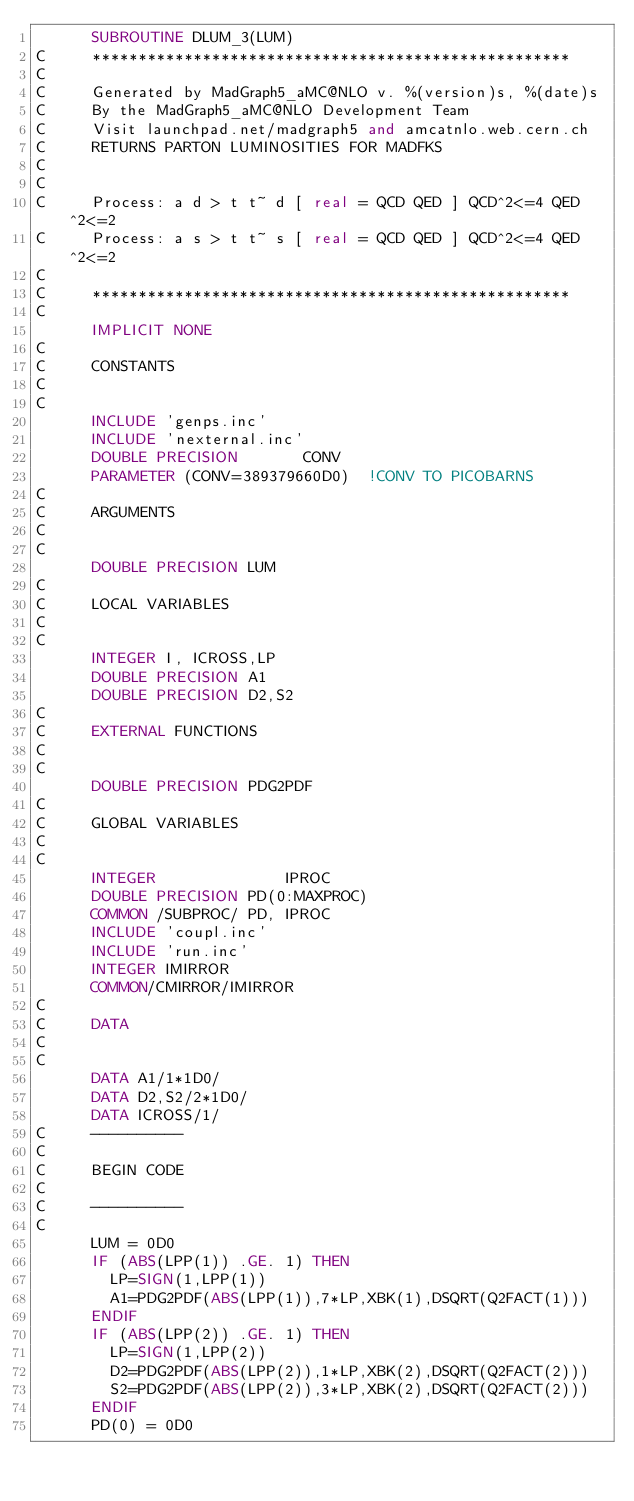<code> <loc_0><loc_0><loc_500><loc_500><_FORTRAN_>      SUBROUTINE DLUM_3(LUM)
C     ****************************************************            
C         
C     Generated by MadGraph5_aMC@NLO v. %(version)s, %(date)s
C     By the MadGraph5_aMC@NLO Development Team
C     Visit launchpad.net/madgraph5 and amcatnlo.web.cern.ch
C     RETURNS PARTON LUMINOSITIES FOR MADFKS                          
C        
C     
C     Process: a d > t t~ d [ real = QCD QED ] QCD^2<=4 QED^2<=2
C     Process: a s > t t~ s [ real = QCD QED ] QCD^2<=4 QED^2<=2
C     
C     ****************************************************            
C         
      IMPLICIT NONE
C     
C     CONSTANTS                                                       
C         
C     
      INCLUDE 'genps.inc'
      INCLUDE 'nexternal.inc'
      DOUBLE PRECISION       CONV
      PARAMETER (CONV=389379660D0)  !CONV TO PICOBARNS             
C     
C     ARGUMENTS                                                       
C         
C     
      DOUBLE PRECISION LUM
C     
C     LOCAL VARIABLES                                                 
C         
C     
      INTEGER I, ICROSS,LP
      DOUBLE PRECISION A1
      DOUBLE PRECISION D2,S2
C     
C     EXTERNAL FUNCTIONS                                              
C         
C     
      DOUBLE PRECISION PDG2PDF
C     
C     GLOBAL VARIABLES                                                
C         
C     
      INTEGER              IPROC
      DOUBLE PRECISION PD(0:MAXPROC)
      COMMON /SUBPROC/ PD, IPROC
      INCLUDE 'coupl.inc'
      INCLUDE 'run.inc'
      INTEGER IMIRROR
      COMMON/CMIRROR/IMIRROR
C     
C     DATA                                                            
C         
C     
      DATA A1/1*1D0/
      DATA D2,S2/2*1D0/
      DATA ICROSS/1/
C     ----------                                                      
C         
C     BEGIN CODE                                                      
C         
C     ----------                                                      
C         
      LUM = 0D0
      IF (ABS(LPP(1)) .GE. 1) THEN
        LP=SIGN(1,LPP(1))
        A1=PDG2PDF(ABS(LPP(1)),7*LP,XBK(1),DSQRT(Q2FACT(1)))
      ENDIF
      IF (ABS(LPP(2)) .GE. 1) THEN
        LP=SIGN(1,LPP(2))
        D2=PDG2PDF(ABS(LPP(2)),1*LP,XBK(2),DSQRT(Q2FACT(2)))
        S2=PDG2PDF(ABS(LPP(2)),3*LP,XBK(2),DSQRT(Q2FACT(2)))
      ENDIF
      PD(0) = 0D0</code> 